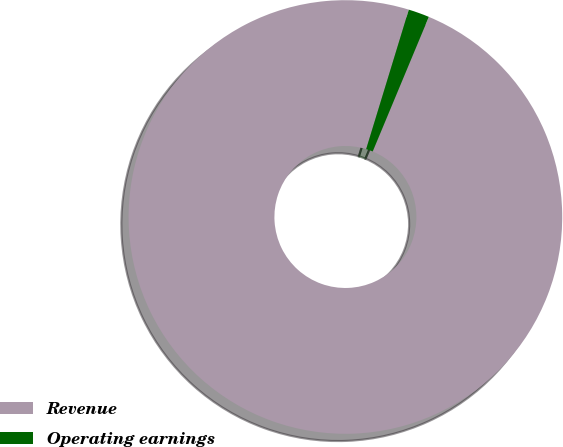Convert chart. <chart><loc_0><loc_0><loc_500><loc_500><pie_chart><fcel>Revenue<fcel>Operating earnings<nl><fcel>98.44%<fcel>1.56%<nl></chart> 